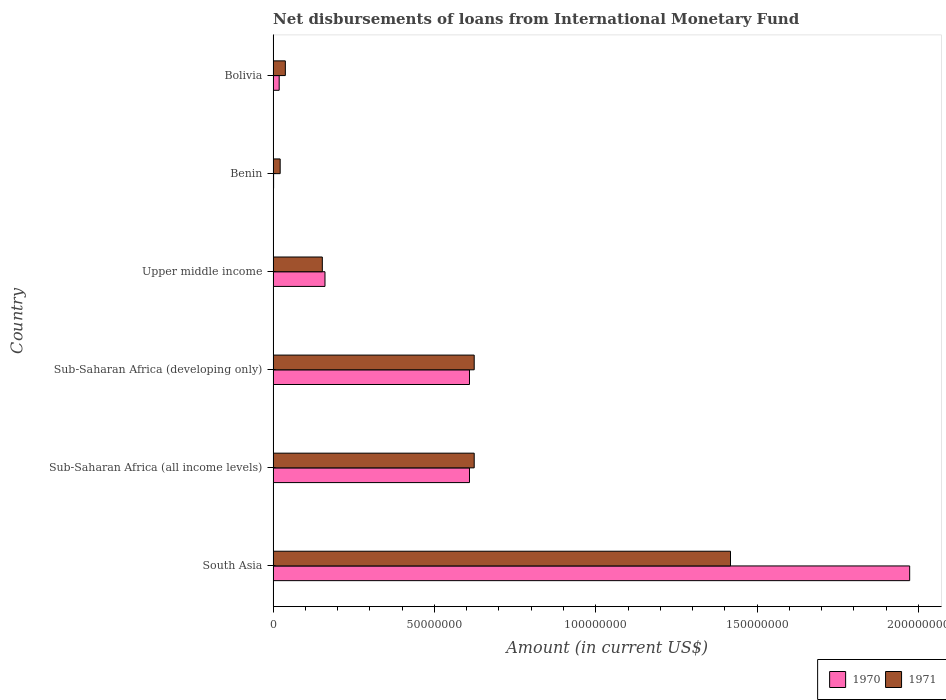How many groups of bars are there?
Provide a short and direct response. 6. In how many cases, is the number of bars for a given country not equal to the number of legend labels?
Offer a terse response. 0. What is the amount of loans disbursed in 1971 in South Asia?
Keep it short and to the point. 1.42e+08. Across all countries, what is the maximum amount of loans disbursed in 1970?
Give a very brief answer. 1.97e+08. Across all countries, what is the minimum amount of loans disbursed in 1970?
Offer a terse response. 1.45e+05. In which country was the amount of loans disbursed in 1971 minimum?
Provide a short and direct response. Benin. What is the total amount of loans disbursed in 1970 in the graph?
Your answer should be compact. 3.37e+08. What is the difference between the amount of loans disbursed in 1970 in South Asia and that in Sub-Saharan Africa (developing only)?
Make the answer very short. 1.36e+08. What is the difference between the amount of loans disbursed in 1970 in Benin and the amount of loans disbursed in 1971 in Sub-Saharan Africa (developing only)?
Make the answer very short. -6.22e+07. What is the average amount of loans disbursed in 1970 per country?
Offer a terse response. 5.62e+07. What is the difference between the amount of loans disbursed in 1971 and amount of loans disbursed in 1970 in Benin?
Your response must be concise. 2.04e+06. What is the ratio of the amount of loans disbursed in 1971 in Benin to that in Sub-Saharan Africa (developing only)?
Make the answer very short. 0.04. Is the amount of loans disbursed in 1971 in South Asia less than that in Sub-Saharan Africa (developing only)?
Give a very brief answer. No. What is the difference between the highest and the second highest amount of loans disbursed in 1971?
Offer a terse response. 7.94e+07. What is the difference between the highest and the lowest amount of loans disbursed in 1971?
Your answer should be very brief. 1.40e+08. Is the sum of the amount of loans disbursed in 1970 in Bolivia and Upper middle income greater than the maximum amount of loans disbursed in 1971 across all countries?
Your response must be concise. No. What does the 1st bar from the top in Benin represents?
Ensure brevity in your answer.  1971. How many bars are there?
Provide a succinct answer. 12. Are all the bars in the graph horizontal?
Provide a succinct answer. Yes. How many countries are there in the graph?
Your answer should be compact. 6. Does the graph contain any zero values?
Give a very brief answer. No. Where does the legend appear in the graph?
Provide a succinct answer. Bottom right. What is the title of the graph?
Your answer should be very brief. Net disbursements of loans from International Monetary Fund. What is the label or title of the Y-axis?
Offer a terse response. Country. What is the Amount (in current US$) of 1970 in South Asia?
Give a very brief answer. 1.97e+08. What is the Amount (in current US$) of 1971 in South Asia?
Give a very brief answer. 1.42e+08. What is the Amount (in current US$) in 1970 in Sub-Saharan Africa (all income levels)?
Your answer should be very brief. 6.09e+07. What is the Amount (in current US$) in 1971 in Sub-Saharan Africa (all income levels)?
Offer a terse response. 6.23e+07. What is the Amount (in current US$) of 1970 in Sub-Saharan Africa (developing only)?
Ensure brevity in your answer.  6.09e+07. What is the Amount (in current US$) in 1971 in Sub-Saharan Africa (developing only)?
Your answer should be very brief. 6.23e+07. What is the Amount (in current US$) in 1970 in Upper middle income?
Your answer should be compact. 1.61e+07. What is the Amount (in current US$) in 1971 in Upper middle income?
Offer a very short reply. 1.52e+07. What is the Amount (in current US$) of 1970 in Benin?
Keep it short and to the point. 1.45e+05. What is the Amount (in current US$) in 1971 in Benin?
Your answer should be compact. 2.19e+06. What is the Amount (in current US$) in 1970 in Bolivia?
Offer a very short reply. 1.88e+06. What is the Amount (in current US$) of 1971 in Bolivia?
Keep it short and to the point. 3.79e+06. Across all countries, what is the maximum Amount (in current US$) of 1970?
Make the answer very short. 1.97e+08. Across all countries, what is the maximum Amount (in current US$) in 1971?
Your answer should be very brief. 1.42e+08. Across all countries, what is the minimum Amount (in current US$) in 1970?
Your response must be concise. 1.45e+05. Across all countries, what is the minimum Amount (in current US$) of 1971?
Keep it short and to the point. 2.19e+06. What is the total Amount (in current US$) in 1970 in the graph?
Your response must be concise. 3.37e+08. What is the total Amount (in current US$) in 1971 in the graph?
Your answer should be compact. 2.88e+08. What is the difference between the Amount (in current US$) of 1970 in South Asia and that in Sub-Saharan Africa (all income levels)?
Your response must be concise. 1.36e+08. What is the difference between the Amount (in current US$) of 1971 in South Asia and that in Sub-Saharan Africa (all income levels)?
Provide a succinct answer. 7.94e+07. What is the difference between the Amount (in current US$) in 1970 in South Asia and that in Sub-Saharan Africa (developing only)?
Provide a short and direct response. 1.36e+08. What is the difference between the Amount (in current US$) in 1971 in South Asia and that in Sub-Saharan Africa (developing only)?
Your answer should be compact. 7.94e+07. What is the difference between the Amount (in current US$) of 1970 in South Asia and that in Upper middle income?
Offer a terse response. 1.81e+08. What is the difference between the Amount (in current US$) of 1971 in South Asia and that in Upper middle income?
Provide a short and direct response. 1.26e+08. What is the difference between the Amount (in current US$) in 1970 in South Asia and that in Benin?
Make the answer very short. 1.97e+08. What is the difference between the Amount (in current US$) in 1971 in South Asia and that in Benin?
Your response must be concise. 1.40e+08. What is the difference between the Amount (in current US$) of 1970 in South Asia and that in Bolivia?
Your answer should be very brief. 1.95e+08. What is the difference between the Amount (in current US$) of 1971 in South Asia and that in Bolivia?
Your answer should be very brief. 1.38e+08. What is the difference between the Amount (in current US$) in 1971 in Sub-Saharan Africa (all income levels) and that in Sub-Saharan Africa (developing only)?
Offer a terse response. 0. What is the difference between the Amount (in current US$) in 1970 in Sub-Saharan Africa (all income levels) and that in Upper middle income?
Make the answer very short. 4.48e+07. What is the difference between the Amount (in current US$) in 1971 in Sub-Saharan Africa (all income levels) and that in Upper middle income?
Offer a terse response. 4.71e+07. What is the difference between the Amount (in current US$) of 1970 in Sub-Saharan Africa (all income levels) and that in Benin?
Make the answer very short. 6.07e+07. What is the difference between the Amount (in current US$) in 1971 in Sub-Saharan Africa (all income levels) and that in Benin?
Keep it short and to the point. 6.01e+07. What is the difference between the Amount (in current US$) in 1970 in Sub-Saharan Africa (all income levels) and that in Bolivia?
Your answer should be compact. 5.90e+07. What is the difference between the Amount (in current US$) of 1971 in Sub-Saharan Africa (all income levels) and that in Bolivia?
Offer a terse response. 5.85e+07. What is the difference between the Amount (in current US$) in 1970 in Sub-Saharan Africa (developing only) and that in Upper middle income?
Your answer should be very brief. 4.48e+07. What is the difference between the Amount (in current US$) in 1971 in Sub-Saharan Africa (developing only) and that in Upper middle income?
Keep it short and to the point. 4.71e+07. What is the difference between the Amount (in current US$) of 1970 in Sub-Saharan Africa (developing only) and that in Benin?
Offer a terse response. 6.07e+07. What is the difference between the Amount (in current US$) of 1971 in Sub-Saharan Africa (developing only) and that in Benin?
Your response must be concise. 6.01e+07. What is the difference between the Amount (in current US$) in 1970 in Sub-Saharan Africa (developing only) and that in Bolivia?
Give a very brief answer. 5.90e+07. What is the difference between the Amount (in current US$) in 1971 in Sub-Saharan Africa (developing only) and that in Bolivia?
Offer a terse response. 5.85e+07. What is the difference between the Amount (in current US$) of 1970 in Upper middle income and that in Benin?
Keep it short and to the point. 1.59e+07. What is the difference between the Amount (in current US$) of 1971 in Upper middle income and that in Benin?
Provide a succinct answer. 1.31e+07. What is the difference between the Amount (in current US$) of 1970 in Upper middle income and that in Bolivia?
Ensure brevity in your answer.  1.42e+07. What is the difference between the Amount (in current US$) of 1971 in Upper middle income and that in Bolivia?
Your answer should be very brief. 1.15e+07. What is the difference between the Amount (in current US$) of 1970 in Benin and that in Bolivia?
Your answer should be very brief. -1.73e+06. What is the difference between the Amount (in current US$) of 1971 in Benin and that in Bolivia?
Your answer should be compact. -1.60e+06. What is the difference between the Amount (in current US$) of 1970 in South Asia and the Amount (in current US$) of 1971 in Sub-Saharan Africa (all income levels)?
Provide a short and direct response. 1.35e+08. What is the difference between the Amount (in current US$) in 1970 in South Asia and the Amount (in current US$) in 1971 in Sub-Saharan Africa (developing only)?
Give a very brief answer. 1.35e+08. What is the difference between the Amount (in current US$) of 1970 in South Asia and the Amount (in current US$) of 1971 in Upper middle income?
Keep it short and to the point. 1.82e+08. What is the difference between the Amount (in current US$) of 1970 in South Asia and the Amount (in current US$) of 1971 in Benin?
Make the answer very short. 1.95e+08. What is the difference between the Amount (in current US$) in 1970 in South Asia and the Amount (in current US$) in 1971 in Bolivia?
Ensure brevity in your answer.  1.93e+08. What is the difference between the Amount (in current US$) of 1970 in Sub-Saharan Africa (all income levels) and the Amount (in current US$) of 1971 in Sub-Saharan Africa (developing only)?
Provide a succinct answer. -1.46e+06. What is the difference between the Amount (in current US$) of 1970 in Sub-Saharan Africa (all income levels) and the Amount (in current US$) of 1971 in Upper middle income?
Your answer should be very brief. 4.56e+07. What is the difference between the Amount (in current US$) in 1970 in Sub-Saharan Africa (all income levels) and the Amount (in current US$) in 1971 in Benin?
Offer a very short reply. 5.87e+07. What is the difference between the Amount (in current US$) in 1970 in Sub-Saharan Africa (all income levels) and the Amount (in current US$) in 1971 in Bolivia?
Provide a short and direct response. 5.71e+07. What is the difference between the Amount (in current US$) in 1970 in Sub-Saharan Africa (developing only) and the Amount (in current US$) in 1971 in Upper middle income?
Your response must be concise. 4.56e+07. What is the difference between the Amount (in current US$) of 1970 in Sub-Saharan Africa (developing only) and the Amount (in current US$) of 1971 in Benin?
Your answer should be very brief. 5.87e+07. What is the difference between the Amount (in current US$) in 1970 in Sub-Saharan Africa (developing only) and the Amount (in current US$) in 1971 in Bolivia?
Your response must be concise. 5.71e+07. What is the difference between the Amount (in current US$) in 1970 in Upper middle income and the Amount (in current US$) in 1971 in Benin?
Give a very brief answer. 1.39e+07. What is the difference between the Amount (in current US$) of 1970 in Upper middle income and the Amount (in current US$) of 1971 in Bolivia?
Give a very brief answer. 1.23e+07. What is the difference between the Amount (in current US$) of 1970 in Benin and the Amount (in current US$) of 1971 in Bolivia?
Ensure brevity in your answer.  -3.64e+06. What is the average Amount (in current US$) of 1970 per country?
Your answer should be compact. 5.62e+07. What is the average Amount (in current US$) of 1971 per country?
Your answer should be compact. 4.79e+07. What is the difference between the Amount (in current US$) of 1970 and Amount (in current US$) of 1971 in South Asia?
Keep it short and to the point. 5.55e+07. What is the difference between the Amount (in current US$) of 1970 and Amount (in current US$) of 1971 in Sub-Saharan Africa (all income levels)?
Ensure brevity in your answer.  -1.46e+06. What is the difference between the Amount (in current US$) in 1970 and Amount (in current US$) in 1971 in Sub-Saharan Africa (developing only)?
Your answer should be compact. -1.46e+06. What is the difference between the Amount (in current US$) in 1970 and Amount (in current US$) in 1971 in Upper middle income?
Provide a short and direct response. 8.24e+05. What is the difference between the Amount (in current US$) in 1970 and Amount (in current US$) in 1971 in Benin?
Provide a short and direct response. -2.04e+06. What is the difference between the Amount (in current US$) of 1970 and Amount (in current US$) of 1971 in Bolivia?
Offer a very short reply. -1.91e+06. What is the ratio of the Amount (in current US$) in 1970 in South Asia to that in Sub-Saharan Africa (all income levels)?
Keep it short and to the point. 3.24. What is the ratio of the Amount (in current US$) of 1971 in South Asia to that in Sub-Saharan Africa (all income levels)?
Make the answer very short. 2.27. What is the ratio of the Amount (in current US$) in 1970 in South Asia to that in Sub-Saharan Africa (developing only)?
Offer a very short reply. 3.24. What is the ratio of the Amount (in current US$) of 1971 in South Asia to that in Sub-Saharan Africa (developing only)?
Make the answer very short. 2.27. What is the ratio of the Amount (in current US$) in 1970 in South Asia to that in Upper middle income?
Provide a short and direct response. 12.27. What is the ratio of the Amount (in current US$) in 1971 in South Asia to that in Upper middle income?
Offer a very short reply. 9.29. What is the ratio of the Amount (in current US$) in 1970 in South Asia to that in Benin?
Give a very brief answer. 1360.52. What is the ratio of the Amount (in current US$) of 1971 in South Asia to that in Benin?
Offer a very short reply. 64.84. What is the ratio of the Amount (in current US$) in 1970 in South Asia to that in Bolivia?
Offer a terse response. 104.99. What is the ratio of the Amount (in current US$) of 1971 in South Asia to that in Bolivia?
Ensure brevity in your answer.  37.43. What is the ratio of the Amount (in current US$) of 1971 in Sub-Saharan Africa (all income levels) to that in Sub-Saharan Africa (developing only)?
Offer a terse response. 1. What is the ratio of the Amount (in current US$) in 1970 in Sub-Saharan Africa (all income levels) to that in Upper middle income?
Offer a terse response. 3.79. What is the ratio of the Amount (in current US$) in 1971 in Sub-Saharan Africa (all income levels) to that in Upper middle income?
Keep it short and to the point. 4.09. What is the ratio of the Amount (in current US$) of 1970 in Sub-Saharan Africa (all income levels) to that in Benin?
Your answer should be very brief. 419.7. What is the ratio of the Amount (in current US$) of 1971 in Sub-Saharan Africa (all income levels) to that in Benin?
Offer a very short reply. 28.51. What is the ratio of the Amount (in current US$) of 1970 in Sub-Saharan Africa (all income levels) to that in Bolivia?
Give a very brief answer. 32.39. What is the ratio of the Amount (in current US$) of 1971 in Sub-Saharan Africa (all income levels) to that in Bolivia?
Keep it short and to the point. 16.46. What is the ratio of the Amount (in current US$) in 1970 in Sub-Saharan Africa (developing only) to that in Upper middle income?
Your answer should be compact. 3.79. What is the ratio of the Amount (in current US$) of 1971 in Sub-Saharan Africa (developing only) to that in Upper middle income?
Give a very brief answer. 4.09. What is the ratio of the Amount (in current US$) of 1970 in Sub-Saharan Africa (developing only) to that in Benin?
Your answer should be compact. 419.7. What is the ratio of the Amount (in current US$) in 1971 in Sub-Saharan Africa (developing only) to that in Benin?
Keep it short and to the point. 28.51. What is the ratio of the Amount (in current US$) of 1970 in Sub-Saharan Africa (developing only) to that in Bolivia?
Offer a terse response. 32.39. What is the ratio of the Amount (in current US$) of 1971 in Sub-Saharan Africa (developing only) to that in Bolivia?
Make the answer very short. 16.46. What is the ratio of the Amount (in current US$) of 1970 in Upper middle income to that in Benin?
Offer a terse response. 110.86. What is the ratio of the Amount (in current US$) of 1971 in Upper middle income to that in Benin?
Provide a short and direct response. 6.98. What is the ratio of the Amount (in current US$) of 1970 in Upper middle income to that in Bolivia?
Make the answer very short. 8.55. What is the ratio of the Amount (in current US$) in 1971 in Upper middle income to that in Bolivia?
Offer a very short reply. 4.03. What is the ratio of the Amount (in current US$) of 1970 in Benin to that in Bolivia?
Offer a terse response. 0.08. What is the ratio of the Amount (in current US$) in 1971 in Benin to that in Bolivia?
Give a very brief answer. 0.58. What is the difference between the highest and the second highest Amount (in current US$) in 1970?
Provide a short and direct response. 1.36e+08. What is the difference between the highest and the second highest Amount (in current US$) in 1971?
Provide a succinct answer. 7.94e+07. What is the difference between the highest and the lowest Amount (in current US$) in 1970?
Your answer should be very brief. 1.97e+08. What is the difference between the highest and the lowest Amount (in current US$) in 1971?
Make the answer very short. 1.40e+08. 